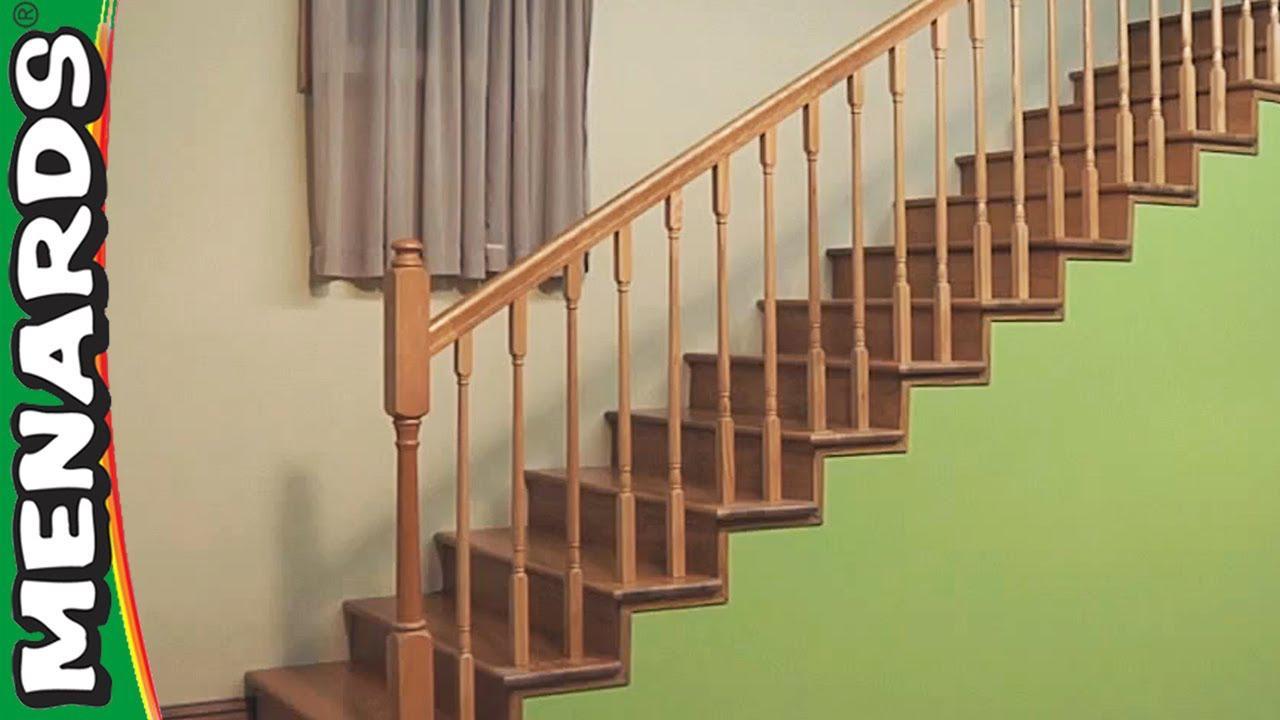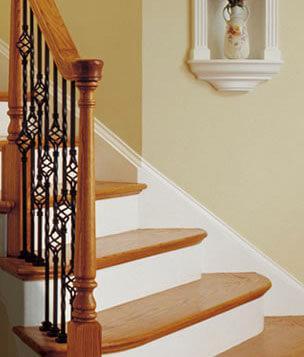The first image is the image on the left, the second image is the image on the right. For the images displayed, is the sentence "In at least one image there are white stair covered with brown wood top next to a black metal ball railing." factually correct? Answer yes or no. Yes. The first image is the image on the left, the second image is the image on the right. Examine the images to the left and right. Is the description "One stair railing is brown and the other is black." accurate? Answer yes or no. Yes. 